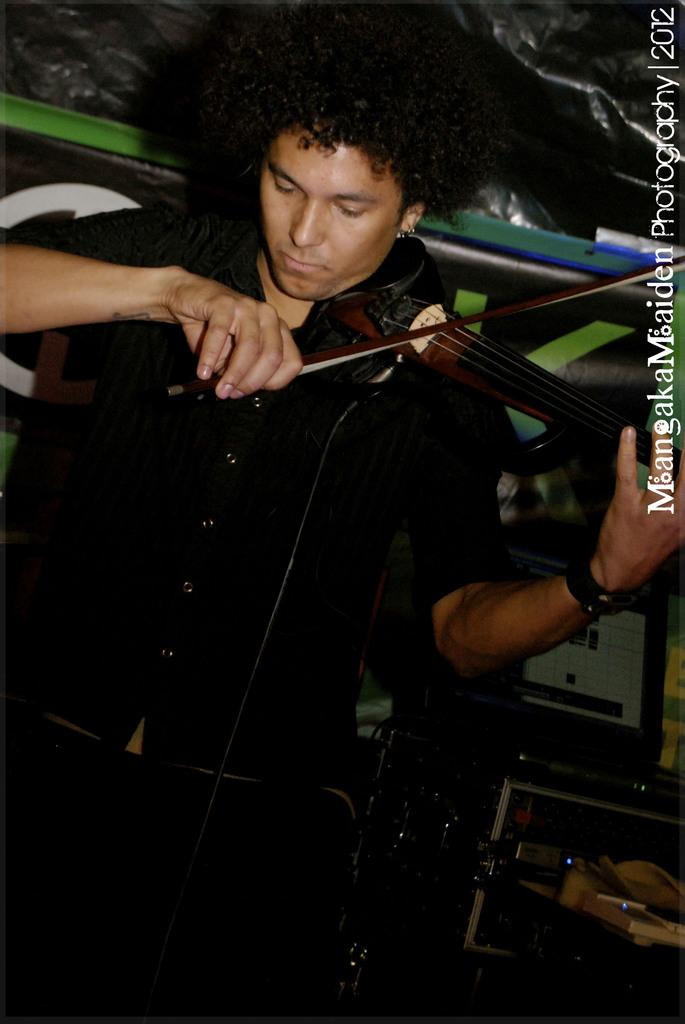What is the man in the image wearing? The man is wearing a black shirt and trousers. What is the man doing in the image? The man is playing a guitar. What object is near the man in the image? The man is standing near a steel box. Can you describe any additional features of the image? There is a watermark on the left side of the image. What type of suit is the man wearing in the image? The man is not wearing a suit in the image; he is wearing a black shirt and trousers. Can you tell me the title of the prose that the man is reading in the image? There is no prose or book visible in the image; the man is playing a guitar. 